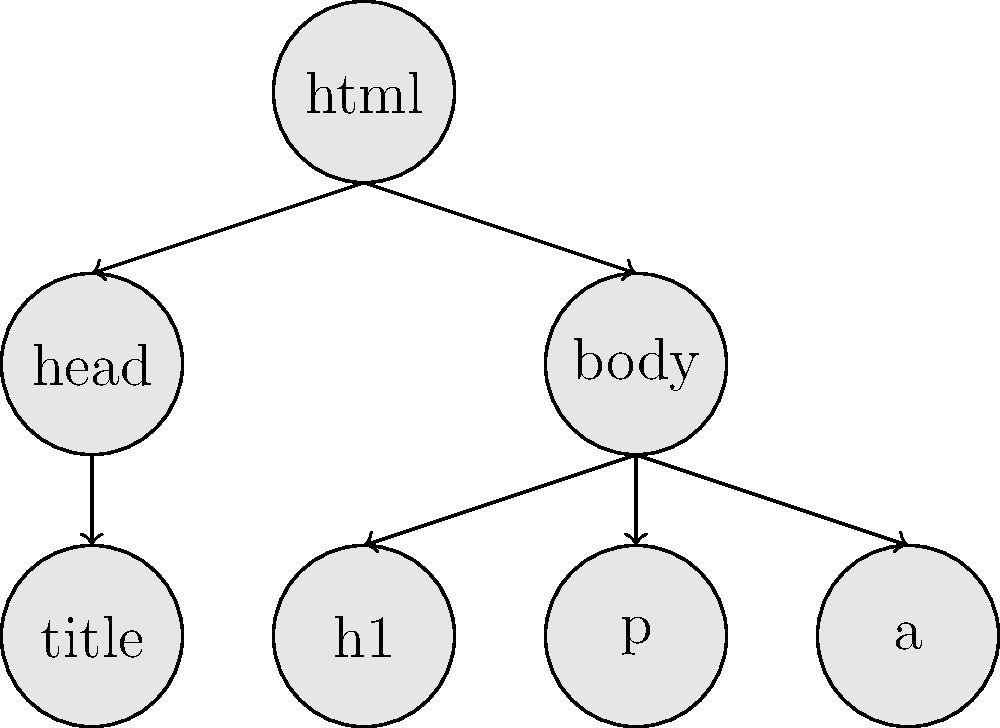Given the DOM tree structure shown in the diagram, which HTML element is the parent of both the `h1` and `p` elements? To determine the parent of both the `h1` and `p` elements, let's analyze the DOM tree structure step-by-step:

1. The root of the tree is the `html` element.
2. The `html` element has two children: `head` and `body`.
3. The `head` element has one child: `title`.
4. The `body` element has three children: `h1`, `p`, and `a`.
5. Both `h1` and `p` are directly connected to the `body` element with arrows.

Therefore, we can conclude that the `body` element is the parent of both the `h1` and `p` elements in this DOM tree structure.

This understanding of the DOM tree structure is crucial for frontend developers working with TypeScript, as it helps in manipulating and traversing the document structure programmatically.
Answer: body 